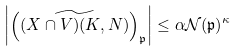Convert formula to latex. <formula><loc_0><loc_0><loc_500><loc_500>\left | \left ( \widetilde { ( X \cap V ) ( K , N ) } \right ) _ { \mathfrak { p } } \right | \leq \alpha \mathcal { N } ( \mathfrak { p } ) ^ { \kappa }</formula> 